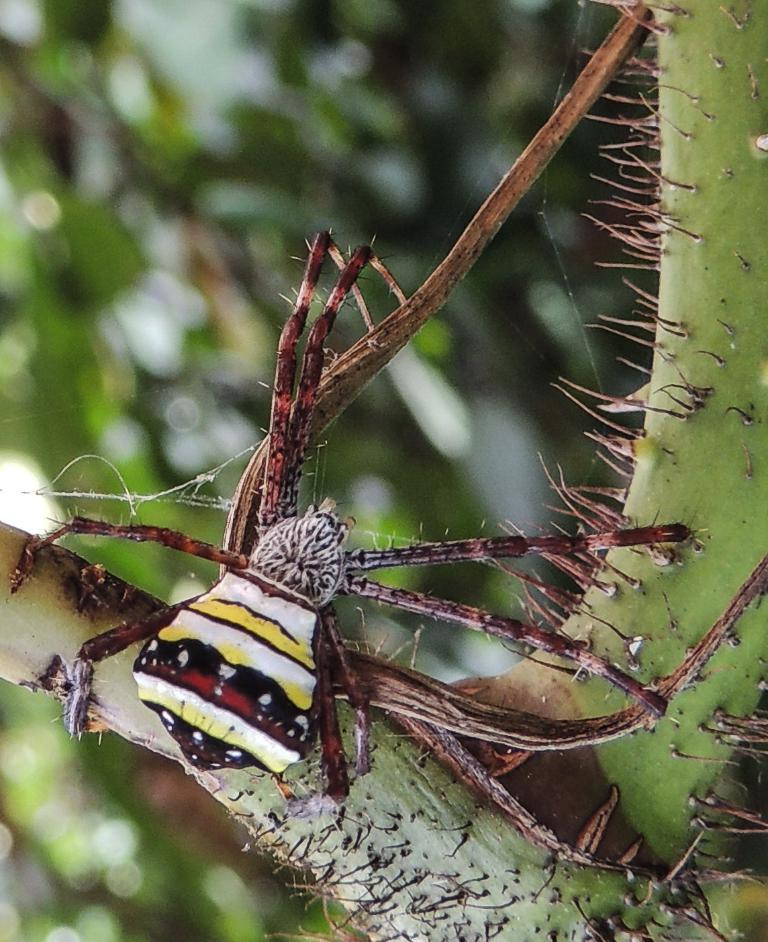What type of creature is present in the image? There is an insect in the image. Where is the insect located? The insect is on a tree. Can you describe the background of the image? The background of the image is blurred. What type of test is being conducted in the image? There is no test being conducted in the image; it features an insect on a tree with a blurred background. 